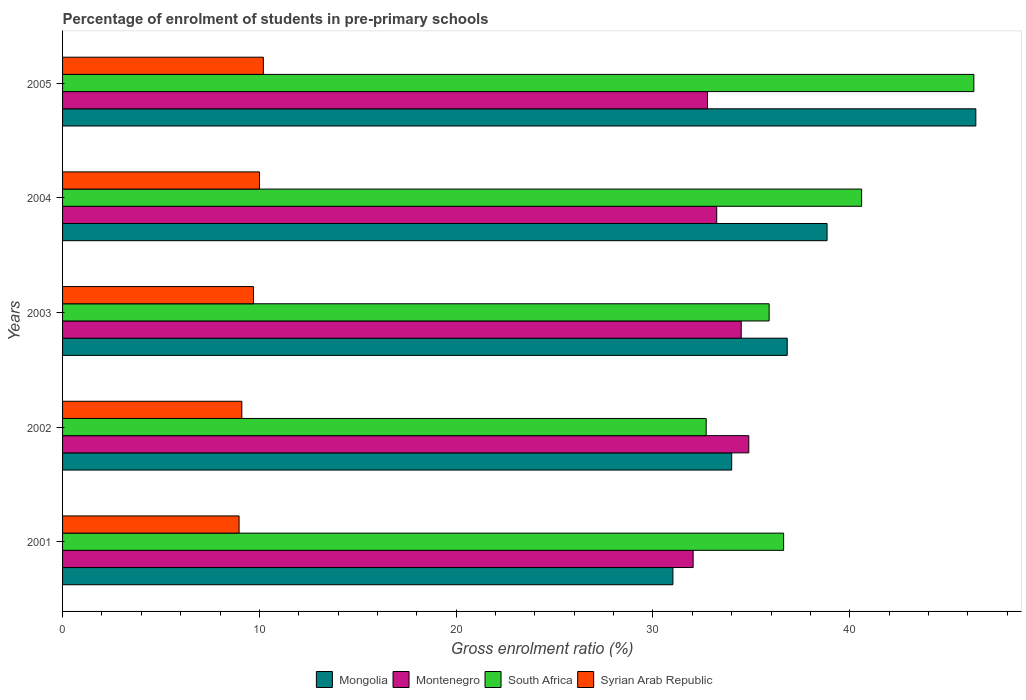How many different coloured bars are there?
Keep it short and to the point. 4. How many groups of bars are there?
Offer a terse response. 5. Are the number of bars per tick equal to the number of legend labels?
Your response must be concise. Yes. Are the number of bars on each tick of the Y-axis equal?
Provide a succinct answer. Yes. What is the percentage of students enrolled in pre-primary schools in Syrian Arab Republic in 2001?
Provide a succinct answer. 8.97. Across all years, what is the maximum percentage of students enrolled in pre-primary schools in Montenegro?
Offer a terse response. 34.87. Across all years, what is the minimum percentage of students enrolled in pre-primary schools in Mongolia?
Offer a terse response. 31.01. In which year was the percentage of students enrolled in pre-primary schools in South Africa maximum?
Provide a succinct answer. 2005. What is the total percentage of students enrolled in pre-primary schools in Mongolia in the graph?
Offer a very short reply. 187.09. What is the difference between the percentage of students enrolled in pre-primary schools in South Africa in 2001 and that in 2005?
Your response must be concise. -9.67. What is the difference between the percentage of students enrolled in pre-primary schools in Syrian Arab Republic in 2005 and the percentage of students enrolled in pre-primary schools in South Africa in 2002?
Provide a short and direct response. -22.5. What is the average percentage of students enrolled in pre-primary schools in Mongolia per year?
Your answer should be very brief. 37.42. In the year 2002, what is the difference between the percentage of students enrolled in pre-primary schools in Montenegro and percentage of students enrolled in pre-primary schools in Syrian Arab Republic?
Give a very brief answer. 25.76. What is the ratio of the percentage of students enrolled in pre-primary schools in South Africa in 2002 to that in 2004?
Keep it short and to the point. 0.81. Is the percentage of students enrolled in pre-primary schools in Syrian Arab Republic in 2001 less than that in 2005?
Keep it short and to the point. Yes. What is the difference between the highest and the second highest percentage of students enrolled in pre-primary schools in Mongolia?
Offer a terse response. 7.56. What is the difference between the highest and the lowest percentage of students enrolled in pre-primary schools in South Africa?
Provide a succinct answer. 13.6. Is the sum of the percentage of students enrolled in pre-primary schools in Montenegro in 2001 and 2005 greater than the maximum percentage of students enrolled in pre-primary schools in South Africa across all years?
Your response must be concise. Yes. Is it the case that in every year, the sum of the percentage of students enrolled in pre-primary schools in Mongolia and percentage of students enrolled in pre-primary schools in Syrian Arab Republic is greater than the sum of percentage of students enrolled in pre-primary schools in Montenegro and percentage of students enrolled in pre-primary schools in South Africa?
Provide a succinct answer. Yes. What does the 2nd bar from the top in 2005 represents?
Your answer should be very brief. South Africa. What does the 3rd bar from the bottom in 2003 represents?
Give a very brief answer. South Africa. Is it the case that in every year, the sum of the percentage of students enrolled in pre-primary schools in Syrian Arab Republic and percentage of students enrolled in pre-primary schools in Mongolia is greater than the percentage of students enrolled in pre-primary schools in Montenegro?
Your response must be concise. Yes. Are all the bars in the graph horizontal?
Give a very brief answer. Yes. How many years are there in the graph?
Your answer should be compact. 5. What is the difference between two consecutive major ticks on the X-axis?
Ensure brevity in your answer.  10. Does the graph contain grids?
Your response must be concise. No. How many legend labels are there?
Your answer should be compact. 4. What is the title of the graph?
Provide a succinct answer. Percentage of enrolment of students in pre-primary schools. What is the label or title of the X-axis?
Your response must be concise. Gross enrolment ratio (%). What is the Gross enrolment ratio (%) of Mongolia in 2001?
Make the answer very short. 31.01. What is the Gross enrolment ratio (%) in Montenegro in 2001?
Ensure brevity in your answer.  32.04. What is the Gross enrolment ratio (%) of South Africa in 2001?
Make the answer very short. 36.64. What is the Gross enrolment ratio (%) of Syrian Arab Republic in 2001?
Provide a short and direct response. 8.97. What is the Gross enrolment ratio (%) of Mongolia in 2002?
Make the answer very short. 34. What is the Gross enrolment ratio (%) of Montenegro in 2002?
Provide a short and direct response. 34.87. What is the Gross enrolment ratio (%) in South Africa in 2002?
Ensure brevity in your answer.  32.7. What is the Gross enrolment ratio (%) in Syrian Arab Republic in 2002?
Make the answer very short. 9.11. What is the Gross enrolment ratio (%) in Mongolia in 2003?
Your response must be concise. 36.82. What is the Gross enrolment ratio (%) of Montenegro in 2003?
Your answer should be compact. 34.48. What is the Gross enrolment ratio (%) of South Africa in 2003?
Make the answer very short. 35.9. What is the Gross enrolment ratio (%) of Syrian Arab Republic in 2003?
Make the answer very short. 9.7. What is the Gross enrolment ratio (%) in Mongolia in 2004?
Your response must be concise. 38.85. What is the Gross enrolment ratio (%) of Montenegro in 2004?
Your answer should be compact. 33.24. What is the Gross enrolment ratio (%) in South Africa in 2004?
Offer a very short reply. 40.6. What is the Gross enrolment ratio (%) in Syrian Arab Republic in 2004?
Give a very brief answer. 10. What is the Gross enrolment ratio (%) in Mongolia in 2005?
Offer a very short reply. 46.41. What is the Gross enrolment ratio (%) in Montenegro in 2005?
Give a very brief answer. 32.77. What is the Gross enrolment ratio (%) in South Africa in 2005?
Give a very brief answer. 46.31. What is the Gross enrolment ratio (%) in Syrian Arab Republic in 2005?
Offer a terse response. 10.2. Across all years, what is the maximum Gross enrolment ratio (%) of Mongolia?
Your answer should be compact. 46.41. Across all years, what is the maximum Gross enrolment ratio (%) of Montenegro?
Provide a short and direct response. 34.87. Across all years, what is the maximum Gross enrolment ratio (%) in South Africa?
Offer a terse response. 46.31. Across all years, what is the maximum Gross enrolment ratio (%) of Syrian Arab Republic?
Offer a very short reply. 10.2. Across all years, what is the minimum Gross enrolment ratio (%) of Mongolia?
Offer a terse response. 31.01. Across all years, what is the minimum Gross enrolment ratio (%) in Montenegro?
Provide a succinct answer. 32.04. Across all years, what is the minimum Gross enrolment ratio (%) in South Africa?
Ensure brevity in your answer.  32.7. Across all years, what is the minimum Gross enrolment ratio (%) in Syrian Arab Republic?
Your response must be concise. 8.97. What is the total Gross enrolment ratio (%) of Mongolia in the graph?
Your response must be concise. 187.09. What is the total Gross enrolment ratio (%) in Montenegro in the graph?
Your answer should be compact. 167.4. What is the total Gross enrolment ratio (%) in South Africa in the graph?
Offer a very short reply. 192.15. What is the total Gross enrolment ratio (%) in Syrian Arab Republic in the graph?
Give a very brief answer. 47.99. What is the difference between the Gross enrolment ratio (%) of Mongolia in 2001 and that in 2002?
Provide a short and direct response. -2.99. What is the difference between the Gross enrolment ratio (%) in Montenegro in 2001 and that in 2002?
Provide a succinct answer. -2.83. What is the difference between the Gross enrolment ratio (%) in South Africa in 2001 and that in 2002?
Your answer should be very brief. 3.93. What is the difference between the Gross enrolment ratio (%) of Syrian Arab Republic in 2001 and that in 2002?
Offer a very short reply. -0.14. What is the difference between the Gross enrolment ratio (%) in Mongolia in 2001 and that in 2003?
Your response must be concise. -5.81. What is the difference between the Gross enrolment ratio (%) of Montenegro in 2001 and that in 2003?
Offer a very short reply. -2.44. What is the difference between the Gross enrolment ratio (%) in South Africa in 2001 and that in 2003?
Keep it short and to the point. 0.74. What is the difference between the Gross enrolment ratio (%) of Syrian Arab Republic in 2001 and that in 2003?
Offer a terse response. -0.73. What is the difference between the Gross enrolment ratio (%) of Mongolia in 2001 and that in 2004?
Make the answer very short. -7.83. What is the difference between the Gross enrolment ratio (%) of Montenegro in 2001 and that in 2004?
Give a very brief answer. -1.2. What is the difference between the Gross enrolment ratio (%) in South Africa in 2001 and that in 2004?
Your answer should be very brief. -3.96. What is the difference between the Gross enrolment ratio (%) in Syrian Arab Republic in 2001 and that in 2004?
Keep it short and to the point. -1.04. What is the difference between the Gross enrolment ratio (%) in Mongolia in 2001 and that in 2005?
Your answer should be very brief. -15.39. What is the difference between the Gross enrolment ratio (%) in Montenegro in 2001 and that in 2005?
Provide a succinct answer. -0.73. What is the difference between the Gross enrolment ratio (%) in South Africa in 2001 and that in 2005?
Keep it short and to the point. -9.67. What is the difference between the Gross enrolment ratio (%) of Syrian Arab Republic in 2001 and that in 2005?
Keep it short and to the point. -1.23. What is the difference between the Gross enrolment ratio (%) of Mongolia in 2002 and that in 2003?
Ensure brevity in your answer.  -2.82. What is the difference between the Gross enrolment ratio (%) in Montenegro in 2002 and that in 2003?
Your response must be concise. 0.38. What is the difference between the Gross enrolment ratio (%) of South Africa in 2002 and that in 2003?
Keep it short and to the point. -3.2. What is the difference between the Gross enrolment ratio (%) of Syrian Arab Republic in 2002 and that in 2003?
Your answer should be compact. -0.59. What is the difference between the Gross enrolment ratio (%) of Mongolia in 2002 and that in 2004?
Your answer should be compact. -4.85. What is the difference between the Gross enrolment ratio (%) of Montenegro in 2002 and that in 2004?
Ensure brevity in your answer.  1.63. What is the difference between the Gross enrolment ratio (%) in South Africa in 2002 and that in 2004?
Offer a terse response. -7.9. What is the difference between the Gross enrolment ratio (%) in Syrian Arab Republic in 2002 and that in 2004?
Your response must be concise. -0.9. What is the difference between the Gross enrolment ratio (%) of Mongolia in 2002 and that in 2005?
Your answer should be very brief. -12.4. What is the difference between the Gross enrolment ratio (%) in Montenegro in 2002 and that in 2005?
Make the answer very short. 2.1. What is the difference between the Gross enrolment ratio (%) of South Africa in 2002 and that in 2005?
Offer a terse response. -13.6. What is the difference between the Gross enrolment ratio (%) in Syrian Arab Republic in 2002 and that in 2005?
Your answer should be compact. -1.09. What is the difference between the Gross enrolment ratio (%) of Mongolia in 2003 and that in 2004?
Your answer should be very brief. -2.02. What is the difference between the Gross enrolment ratio (%) of Montenegro in 2003 and that in 2004?
Make the answer very short. 1.25. What is the difference between the Gross enrolment ratio (%) in South Africa in 2003 and that in 2004?
Ensure brevity in your answer.  -4.7. What is the difference between the Gross enrolment ratio (%) in Syrian Arab Republic in 2003 and that in 2004?
Your response must be concise. -0.3. What is the difference between the Gross enrolment ratio (%) in Mongolia in 2003 and that in 2005?
Make the answer very short. -9.58. What is the difference between the Gross enrolment ratio (%) of Montenegro in 2003 and that in 2005?
Your answer should be very brief. 1.71. What is the difference between the Gross enrolment ratio (%) of South Africa in 2003 and that in 2005?
Your answer should be very brief. -10.4. What is the difference between the Gross enrolment ratio (%) in Syrian Arab Republic in 2003 and that in 2005?
Offer a very short reply. -0.5. What is the difference between the Gross enrolment ratio (%) in Mongolia in 2004 and that in 2005?
Your answer should be compact. -7.56. What is the difference between the Gross enrolment ratio (%) of Montenegro in 2004 and that in 2005?
Provide a succinct answer. 0.47. What is the difference between the Gross enrolment ratio (%) in South Africa in 2004 and that in 2005?
Provide a succinct answer. -5.7. What is the difference between the Gross enrolment ratio (%) in Syrian Arab Republic in 2004 and that in 2005?
Keep it short and to the point. -0.2. What is the difference between the Gross enrolment ratio (%) in Mongolia in 2001 and the Gross enrolment ratio (%) in Montenegro in 2002?
Keep it short and to the point. -3.86. What is the difference between the Gross enrolment ratio (%) of Mongolia in 2001 and the Gross enrolment ratio (%) of South Africa in 2002?
Your answer should be very brief. -1.69. What is the difference between the Gross enrolment ratio (%) of Mongolia in 2001 and the Gross enrolment ratio (%) of Syrian Arab Republic in 2002?
Offer a very short reply. 21.9. What is the difference between the Gross enrolment ratio (%) of Montenegro in 2001 and the Gross enrolment ratio (%) of South Africa in 2002?
Provide a short and direct response. -0.66. What is the difference between the Gross enrolment ratio (%) of Montenegro in 2001 and the Gross enrolment ratio (%) of Syrian Arab Republic in 2002?
Keep it short and to the point. 22.93. What is the difference between the Gross enrolment ratio (%) in South Africa in 2001 and the Gross enrolment ratio (%) in Syrian Arab Republic in 2002?
Give a very brief answer. 27.53. What is the difference between the Gross enrolment ratio (%) in Mongolia in 2001 and the Gross enrolment ratio (%) in Montenegro in 2003?
Make the answer very short. -3.47. What is the difference between the Gross enrolment ratio (%) in Mongolia in 2001 and the Gross enrolment ratio (%) in South Africa in 2003?
Offer a terse response. -4.89. What is the difference between the Gross enrolment ratio (%) of Mongolia in 2001 and the Gross enrolment ratio (%) of Syrian Arab Republic in 2003?
Provide a short and direct response. 21.31. What is the difference between the Gross enrolment ratio (%) in Montenegro in 2001 and the Gross enrolment ratio (%) in South Africa in 2003?
Make the answer very short. -3.86. What is the difference between the Gross enrolment ratio (%) in Montenegro in 2001 and the Gross enrolment ratio (%) in Syrian Arab Republic in 2003?
Provide a short and direct response. 22.34. What is the difference between the Gross enrolment ratio (%) of South Africa in 2001 and the Gross enrolment ratio (%) of Syrian Arab Republic in 2003?
Give a very brief answer. 26.94. What is the difference between the Gross enrolment ratio (%) of Mongolia in 2001 and the Gross enrolment ratio (%) of Montenegro in 2004?
Offer a terse response. -2.23. What is the difference between the Gross enrolment ratio (%) in Mongolia in 2001 and the Gross enrolment ratio (%) in South Africa in 2004?
Offer a very short reply. -9.59. What is the difference between the Gross enrolment ratio (%) of Mongolia in 2001 and the Gross enrolment ratio (%) of Syrian Arab Republic in 2004?
Provide a short and direct response. 21.01. What is the difference between the Gross enrolment ratio (%) in Montenegro in 2001 and the Gross enrolment ratio (%) in South Africa in 2004?
Provide a short and direct response. -8.56. What is the difference between the Gross enrolment ratio (%) in Montenegro in 2001 and the Gross enrolment ratio (%) in Syrian Arab Republic in 2004?
Keep it short and to the point. 22.04. What is the difference between the Gross enrolment ratio (%) of South Africa in 2001 and the Gross enrolment ratio (%) of Syrian Arab Republic in 2004?
Offer a terse response. 26.63. What is the difference between the Gross enrolment ratio (%) in Mongolia in 2001 and the Gross enrolment ratio (%) in Montenegro in 2005?
Offer a terse response. -1.76. What is the difference between the Gross enrolment ratio (%) in Mongolia in 2001 and the Gross enrolment ratio (%) in South Africa in 2005?
Provide a succinct answer. -15.29. What is the difference between the Gross enrolment ratio (%) in Mongolia in 2001 and the Gross enrolment ratio (%) in Syrian Arab Republic in 2005?
Your response must be concise. 20.81. What is the difference between the Gross enrolment ratio (%) in Montenegro in 2001 and the Gross enrolment ratio (%) in South Africa in 2005?
Offer a very short reply. -14.26. What is the difference between the Gross enrolment ratio (%) of Montenegro in 2001 and the Gross enrolment ratio (%) of Syrian Arab Republic in 2005?
Provide a short and direct response. 21.84. What is the difference between the Gross enrolment ratio (%) in South Africa in 2001 and the Gross enrolment ratio (%) in Syrian Arab Republic in 2005?
Your response must be concise. 26.44. What is the difference between the Gross enrolment ratio (%) of Mongolia in 2002 and the Gross enrolment ratio (%) of Montenegro in 2003?
Your response must be concise. -0.48. What is the difference between the Gross enrolment ratio (%) of Mongolia in 2002 and the Gross enrolment ratio (%) of South Africa in 2003?
Give a very brief answer. -1.9. What is the difference between the Gross enrolment ratio (%) of Mongolia in 2002 and the Gross enrolment ratio (%) of Syrian Arab Republic in 2003?
Give a very brief answer. 24.3. What is the difference between the Gross enrolment ratio (%) of Montenegro in 2002 and the Gross enrolment ratio (%) of South Africa in 2003?
Provide a short and direct response. -1.03. What is the difference between the Gross enrolment ratio (%) in Montenegro in 2002 and the Gross enrolment ratio (%) in Syrian Arab Republic in 2003?
Your answer should be very brief. 25.17. What is the difference between the Gross enrolment ratio (%) of South Africa in 2002 and the Gross enrolment ratio (%) of Syrian Arab Republic in 2003?
Your answer should be very brief. 23. What is the difference between the Gross enrolment ratio (%) in Mongolia in 2002 and the Gross enrolment ratio (%) in Montenegro in 2004?
Give a very brief answer. 0.76. What is the difference between the Gross enrolment ratio (%) of Mongolia in 2002 and the Gross enrolment ratio (%) of South Africa in 2004?
Provide a short and direct response. -6.6. What is the difference between the Gross enrolment ratio (%) of Mongolia in 2002 and the Gross enrolment ratio (%) of Syrian Arab Republic in 2004?
Provide a succinct answer. 24. What is the difference between the Gross enrolment ratio (%) in Montenegro in 2002 and the Gross enrolment ratio (%) in South Africa in 2004?
Your answer should be compact. -5.73. What is the difference between the Gross enrolment ratio (%) in Montenegro in 2002 and the Gross enrolment ratio (%) in Syrian Arab Republic in 2004?
Keep it short and to the point. 24.86. What is the difference between the Gross enrolment ratio (%) of South Africa in 2002 and the Gross enrolment ratio (%) of Syrian Arab Republic in 2004?
Ensure brevity in your answer.  22.7. What is the difference between the Gross enrolment ratio (%) in Mongolia in 2002 and the Gross enrolment ratio (%) in Montenegro in 2005?
Give a very brief answer. 1.23. What is the difference between the Gross enrolment ratio (%) in Mongolia in 2002 and the Gross enrolment ratio (%) in South Africa in 2005?
Make the answer very short. -12.3. What is the difference between the Gross enrolment ratio (%) in Mongolia in 2002 and the Gross enrolment ratio (%) in Syrian Arab Republic in 2005?
Ensure brevity in your answer.  23.8. What is the difference between the Gross enrolment ratio (%) of Montenegro in 2002 and the Gross enrolment ratio (%) of South Africa in 2005?
Offer a very short reply. -11.44. What is the difference between the Gross enrolment ratio (%) in Montenegro in 2002 and the Gross enrolment ratio (%) in Syrian Arab Republic in 2005?
Your response must be concise. 24.67. What is the difference between the Gross enrolment ratio (%) of South Africa in 2002 and the Gross enrolment ratio (%) of Syrian Arab Republic in 2005?
Make the answer very short. 22.5. What is the difference between the Gross enrolment ratio (%) of Mongolia in 2003 and the Gross enrolment ratio (%) of Montenegro in 2004?
Provide a succinct answer. 3.58. What is the difference between the Gross enrolment ratio (%) of Mongolia in 2003 and the Gross enrolment ratio (%) of South Africa in 2004?
Your answer should be compact. -3.78. What is the difference between the Gross enrolment ratio (%) of Mongolia in 2003 and the Gross enrolment ratio (%) of Syrian Arab Republic in 2004?
Offer a very short reply. 26.82. What is the difference between the Gross enrolment ratio (%) of Montenegro in 2003 and the Gross enrolment ratio (%) of South Africa in 2004?
Make the answer very short. -6.12. What is the difference between the Gross enrolment ratio (%) of Montenegro in 2003 and the Gross enrolment ratio (%) of Syrian Arab Republic in 2004?
Make the answer very short. 24.48. What is the difference between the Gross enrolment ratio (%) of South Africa in 2003 and the Gross enrolment ratio (%) of Syrian Arab Republic in 2004?
Your response must be concise. 25.9. What is the difference between the Gross enrolment ratio (%) in Mongolia in 2003 and the Gross enrolment ratio (%) in Montenegro in 2005?
Offer a terse response. 4.05. What is the difference between the Gross enrolment ratio (%) of Mongolia in 2003 and the Gross enrolment ratio (%) of South Africa in 2005?
Make the answer very short. -9.48. What is the difference between the Gross enrolment ratio (%) of Mongolia in 2003 and the Gross enrolment ratio (%) of Syrian Arab Republic in 2005?
Offer a terse response. 26.62. What is the difference between the Gross enrolment ratio (%) of Montenegro in 2003 and the Gross enrolment ratio (%) of South Africa in 2005?
Offer a very short reply. -11.82. What is the difference between the Gross enrolment ratio (%) of Montenegro in 2003 and the Gross enrolment ratio (%) of Syrian Arab Republic in 2005?
Keep it short and to the point. 24.28. What is the difference between the Gross enrolment ratio (%) in South Africa in 2003 and the Gross enrolment ratio (%) in Syrian Arab Republic in 2005?
Provide a succinct answer. 25.7. What is the difference between the Gross enrolment ratio (%) of Mongolia in 2004 and the Gross enrolment ratio (%) of Montenegro in 2005?
Ensure brevity in your answer.  6.08. What is the difference between the Gross enrolment ratio (%) of Mongolia in 2004 and the Gross enrolment ratio (%) of South Africa in 2005?
Keep it short and to the point. -7.46. What is the difference between the Gross enrolment ratio (%) of Mongolia in 2004 and the Gross enrolment ratio (%) of Syrian Arab Republic in 2005?
Make the answer very short. 28.64. What is the difference between the Gross enrolment ratio (%) of Montenegro in 2004 and the Gross enrolment ratio (%) of South Africa in 2005?
Offer a terse response. -13.07. What is the difference between the Gross enrolment ratio (%) in Montenegro in 2004 and the Gross enrolment ratio (%) in Syrian Arab Republic in 2005?
Give a very brief answer. 23.04. What is the difference between the Gross enrolment ratio (%) in South Africa in 2004 and the Gross enrolment ratio (%) in Syrian Arab Republic in 2005?
Make the answer very short. 30.4. What is the average Gross enrolment ratio (%) of Mongolia per year?
Offer a very short reply. 37.42. What is the average Gross enrolment ratio (%) in Montenegro per year?
Your answer should be very brief. 33.48. What is the average Gross enrolment ratio (%) in South Africa per year?
Your answer should be very brief. 38.43. What is the average Gross enrolment ratio (%) of Syrian Arab Republic per year?
Offer a terse response. 9.6. In the year 2001, what is the difference between the Gross enrolment ratio (%) of Mongolia and Gross enrolment ratio (%) of Montenegro?
Keep it short and to the point. -1.03. In the year 2001, what is the difference between the Gross enrolment ratio (%) in Mongolia and Gross enrolment ratio (%) in South Africa?
Ensure brevity in your answer.  -5.63. In the year 2001, what is the difference between the Gross enrolment ratio (%) of Mongolia and Gross enrolment ratio (%) of Syrian Arab Republic?
Give a very brief answer. 22.04. In the year 2001, what is the difference between the Gross enrolment ratio (%) of Montenegro and Gross enrolment ratio (%) of South Africa?
Provide a succinct answer. -4.6. In the year 2001, what is the difference between the Gross enrolment ratio (%) of Montenegro and Gross enrolment ratio (%) of Syrian Arab Republic?
Provide a short and direct response. 23.07. In the year 2001, what is the difference between the Gross enrolment ratio (%) of South Africa and Gross enrolment ratio (%) of Syrian Arab Republic?
Ensure brevity in your answer.  27.67. In the year 2002, what is the difference between the Gross enrolment ratio (%) in Mongolia and Gross enrolment ratio (%) in Montenegro?
Make the answer very short. -0.87. In the year 2002, what is the difference between the Gross enrolment ratio (%) in Mongolia and Gross enrolment ratio (%) in South Africa?
Make the answer very short. 1.3. In the year 2002, what is the difference between the Gross enrolment ratio (%) in Mongolia and Gross enrolment ratio (%) in Syrian Arab Republic?
Ensure brevity in your answer.  24.89. In the year 2002, what is the difference between the Gross enrolment ratio (%) of Montenegro and Gross enrolment ratio (%) of South Africa?
Give a very brief answer. 2.17. In the year 2002, what is the difference between the Gross enrolment ratio (%) in Montenegro and Gross enrolment ratio (%) in Syrian Arab Republic?
Ensure brevity in your answer.  25.76. In the year 2002, what is the difference between the Gross enrolment ratio (%) of South Africa and Gross enrolment ratio (%) of Syrian Arab Republic?
Your answer should be very brief. 23.6. In the year 2003, what is the difference between the Gross enrolment ratio (%) of Mongolia and Gross enrolment ratio (%) of Montenegro?
Your answer should be compact. 2.34. In the year 2003, what is the difference between the Gross enrolment ratio (%) of Mongolia and Gross enrolment ratio (%) of South Africa?
Your answer should be very brief. 0.92. In the year 2003, what is the difference between the Gross enrolment ratio (%) in Mongolia and Gross enrolment ratio (%) in Syrian Arab Republic?
Provide a succinct answer. 27.12. In the year 2003, what is the difference between the Gross enrolment ratio (%) in Montenegro and Gross enrolment ratio (%) in South Africa?
Your answer should be very brief. -1.42. In the year 2003, what is the difference between the Gross enrolment ratio (%) in Montenegro and Gross enrolment ratio (%) in Syrian Arab Republic?
Your answer should be very brief. 24.78. In the year 2003, what is the difference between the Gross enrolment ratio (%) of South Africa and Gross enrolment ratio (%) of Syrian Arab Republic?
Your answer should be compact. 26.2. In the year 2004, what is the difference between the Gross enrolment ratio (%) of Mongolia and Gross enrolment ratio (%) of Montenegro?
Provide a succinct answer. 5.61. In the year 2004, what is the difference between the Gross enrolment ratio (%) of Mongolia and Gross enrolment ratio (%) of South Africa?
Provide a succinct answer. -1.76. In the year 2004, what is the difference between the Gross enrolment ratio (%) of Mongolia and Gross enrolment ratio (%) of Syrian Arab Republic?
Give a very brief answer. 28.84. In the year 2004, what is the difference between the Gross enrolment ratio (%) in Montenegro and Gross enrolment ratio (%) in South Africa?
Your answer should be compact. -7.36. In the year 2004, what is the difference between the Gross enrolment ratio (%) of Montenegro and Gross enrolment ratio (%) of Syrian Arab Republic?
Provide a short and direct response. 23.23. In the year 2004, what is the difference between the Gross enrolment ratio (%) of South Africa and Gross enrolment ratio (%) of Syrian Arab Republic?
Your answer should be very brief. 30.6. In the year 2005, what is the difference between the Gross enrolment ratio (%) of Mongolia and Gross enrolment ratio (%) of Montenegro?
Give a very brief answer. 13.63. In the year 2005, what is the difference between the Gross enrolment ratio (%) of Mongolia and Gross enrolment ratio (%) of South Africa?
Provide a succinct answer. 0.1. In the year 2005, what is the difference between the Gross enrolment ratio (%) of Mongolia and Gross enrolment ratio (%) of Syrian Arab Republic?
Your answer should be very brief. 36.2. In the year 2005, what is the difference between the Gross enrolment ratio (%) of Montenegro and Gross enrolment ratio (%) of South Africa?
Keep it short and to the point. -13.54. In the year 2005, what is the difference between the Gross enrolment ratio (%) of Montenegro and Gross enrolment ratio (%) of Syrian Arab Republic?
Provide a short and direct response. 22.57. In the year 2005, what is the difference between the Gross enrolment ratio (%) of South Africa and Gross enrolment ratio (%) of Syrian Arab Republic?
Give a very brief answer. 36.1. What is the ratio of the Gross enrolment ratio (%) in Mongolia in 2001 to that in 2002?
Make the answer very short. 0.91. What is the ratio of the Gross enrolment ratio (%) of Montenegro in 2001 to that in 2002?
Keep it short and to the point. 0.92. What is the ratio of the Gross enrolment ratio (%) in South Africa in 2001 to that in 2002?
Provide a short and direct response. 1.12. What is the ratio of the Gross enrolment ratio (%) of Syrian Arab Republic in 2001 to that in 2002?
Give a very brief answer. 0.98. What is the ratio of the Gross enrolment ratio (%) of Mongolia in 2001 to that in 2003?
Provide a short and direct response. 0.84. What is the ratio of the Gross enrolment ratio (%) in Montenegro in 2001 to that in 2003?
Make the answer very short. 0.93. What is the ratio of the Gross enrolment ratio (%) of South Africa in 2001 to that in 2003?
Provide a succinct answer. 1.02. What is the ratio of the Gross enrolment ratio (%) of Syrian Arab Republic in 2001 to that in 2003?
Offer a very short reply. 0.92. What is the ratio of the Gross enrolment ratio (%) in Mongolia in 2001 to that in 2004?
Ensure brevity in your answer.  0.8. What is the ratio of the Gross enrolment ratio (%) of South Africa in 2001 to that in 2004?
Provide a succinct answer. 0.9. What is the ratio of the Gross enrolment ratio (%) in Syrian Arab Republic in 2001 to that in 2004?
Your answer should be compact. 0.9. What is the ratio of the Gross enrolment ratio (%) of Mongolia in 2001 to that in 2005?
Your response must be concise. 0.67. What is the ratio of the Gross enrolment ratio (%) of Montenegro in 2001 to that in 2005?
Your response must be concise. 0.98. What is the ratio of the Gross enrolment ratio (%) of South Africa in 2001 to that in 2005?
Keep it short and to the point. 0.79. What is the ratio of the Gross enrolment ratio (%) of Syrian Arab Republic in 2001 to that in 2005?
Make the answer very short. 0.88. What is the ratio of the Gross enrolment ratio (%) in Mongolia in 2002 to that in 2003?
Your answer should be compact. 0.92. What is the ratio of the Gross enrolment ratio (%) of Montenegro in 2002 to that in 2003?
Ensure brevity in your answer.  1.01. What is the ratio of the Gross enrolment ratio (%) in South Africa in 2002 to that in 2003?
Make the answer very short. 0.91. What is the ratio of the Gross enrolment ratio (%) of Syrian Arab Republic in 2002 to that in 2003?
Make the answer very short. 0.94. What is the ratio of the Gross enrolment ratio (%) of Mongolia in 2002 to that in 2004?
Your answer should be very brief. 0.88. What is the ratio of the Gross enrolment ratio (%) of Montenegro in 2002 to that in 2004?
Offer a terse response. 1.05. What is the ratio of the Gross enrolment ratio (%) in South Africa in 2002 to that in 2004?
Provide a succinct answer. 0.81. What is the ratio of the Gross enrolment ratio (%) in Syrian Arab Republic in 2002 to that in 2004?
Give a very brief answer. 0.91. What is the ratio of the Gross enrolment ratio (%) of Mongolia in 2002 to that in 2005?
Give a very brief answer. 0.73. What is the ratio of the Gross enrolment ratio (%) in Montenegro in 2002 to that in 2005?
Provide a short and direct response. 1.06. What is the ratio of the Gross enrolment ratio (%) of South Africa in 2002 to that in 2005?
Offer a very short reply. 0.71. What is the ratio of the Gross enrolment ratio (%) in Syrian Arab Republic in 2002 to that in 2005?
Make the answer very short. 0.89. What is the ratio of the Gross enrolment ratio (%) in Mongolia in 2003 to that in 2004?
Offer a terse response. 0.95. What is the ratio of the Gross enrolment ratio (%) of Montenegro in 2003 to that in 2004?
Your response must be concise. 1.04. What is the ratio of the Gross enrolment ratio (%) in South Africa in 2003 to that in 2004?
Make the answer very short. 0.88. What is the ratio of the Gross enrolment ratio (%) of Syrian Arab Republic in 2003 to that in 2004?
Make the answer very short. 0.97. What is the ratio of the Gross enrolment ratio (%) in Mongolia in 2003 to that in 2005?
Offer a terse response. 0.79. What is the ratio of the Gross enrolment ratio (%) in Montenegro in 2003 to that in 2005?
Ensure brevity in your answer.  1.05. What is the ratio of the Gross enrolment ratio (%) of South Africa in 2003 to that in 2005?
Offer a very short reply. 0.78. What is the ratio of the Gross enrolment ratio (%) in Syrian Arab Republic in 2003 to that in 2005?
Your answer should be compact. 0.95. What is the ratio of the Gross enrolment ratio (%) in Mongolia in 2004 to that in 2005?
Ensure brevity in your answer.  0.84. What is the ratio of the Gross enrolment ratio (%) of Montenegro in 2004 to that in 2005?
Provide a succinct answer. 1.01. What is the ratio of the Gross enrolment ratio (%) of South Africa in 2004 to that in 2005?
Your response must be concise. 0.88. What is the ratio of the Gross enrolment ratio (%) of Syrian Arab Republic in 2004 to that in 2005?
Provide a succinct answer. 0.98. What is the difference between the highest and the second highest Gross enrolment ratio (%) in Mongolia?
Make the answer very short. 7.56. What is the difference between the highest and the second highest Gross enrolment ratio (%) in Montenegro?
Provide a short and direct response. 0.38. What is the difference between the highest and the second highest Gross enrolment ratio (%) of South Africa?
Offer a terse response. 5.7. What is the difference between the highest and the second highest Gross enrolment ratio (%) in Syrian Arab Republic?
Offer a very short reply. 0.2. What is the difference between the highest and the lowest Gross enrolment ratio (%) of Mongolia?
Offer a very short reply. 15.39. What is the difference between the highest and the lowest Gross enrolment ratio (%) of Montenegro?
Provide a succinct answer. 2.83. What is the difference between the highest and the lowest Gross enrolment ratio (%) in South Africa?
Keep it short and to the point. 13.6. What is the difference between the highest and the lowest Gross enrolment ratio (%) in Syrian Arab Republic?
Provide a short and direct response. 1.23. 